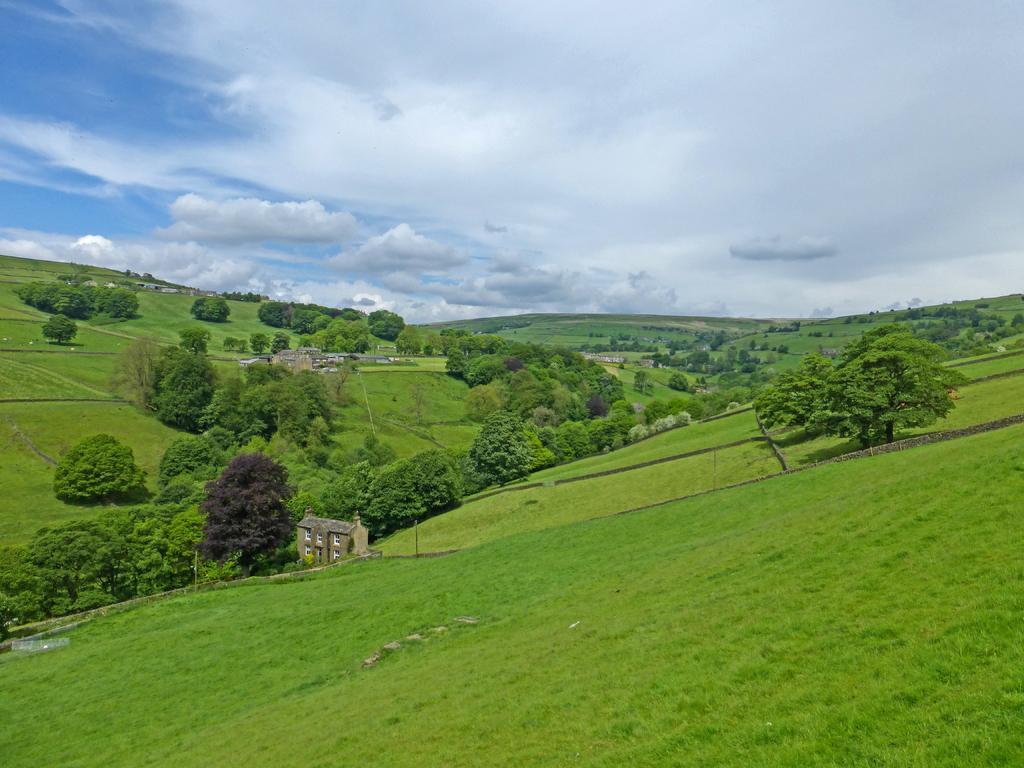Describe this image in one or two sentences. In this image there are trees, buildings. At the bottom of the image there is grass on the surface. In the background of the image there is sky. 